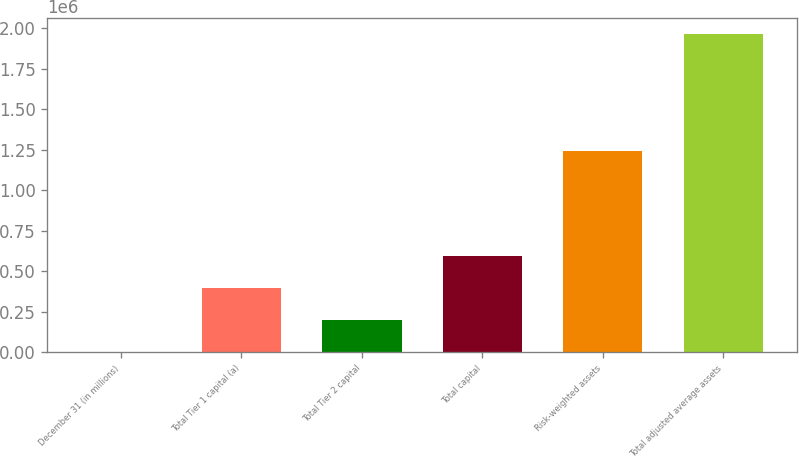Convert chart to OTSL. <chart><loc_0><loc_0><loc_500><loc_500><bar_chart><fcel>December 31 (in millions)<fcel>Total Tier 1 capital (a)<fcel>Total Tier 2 capital<fcel>Total capital<fcel>Risk-weighted assets<fcel>Total adjusted average assets<nl><fcel>2008<fcel>394985<fcel>198497<fcel>591474<fcel>1.24466e+06<fcel>1.9669e+06<nl></chart> 